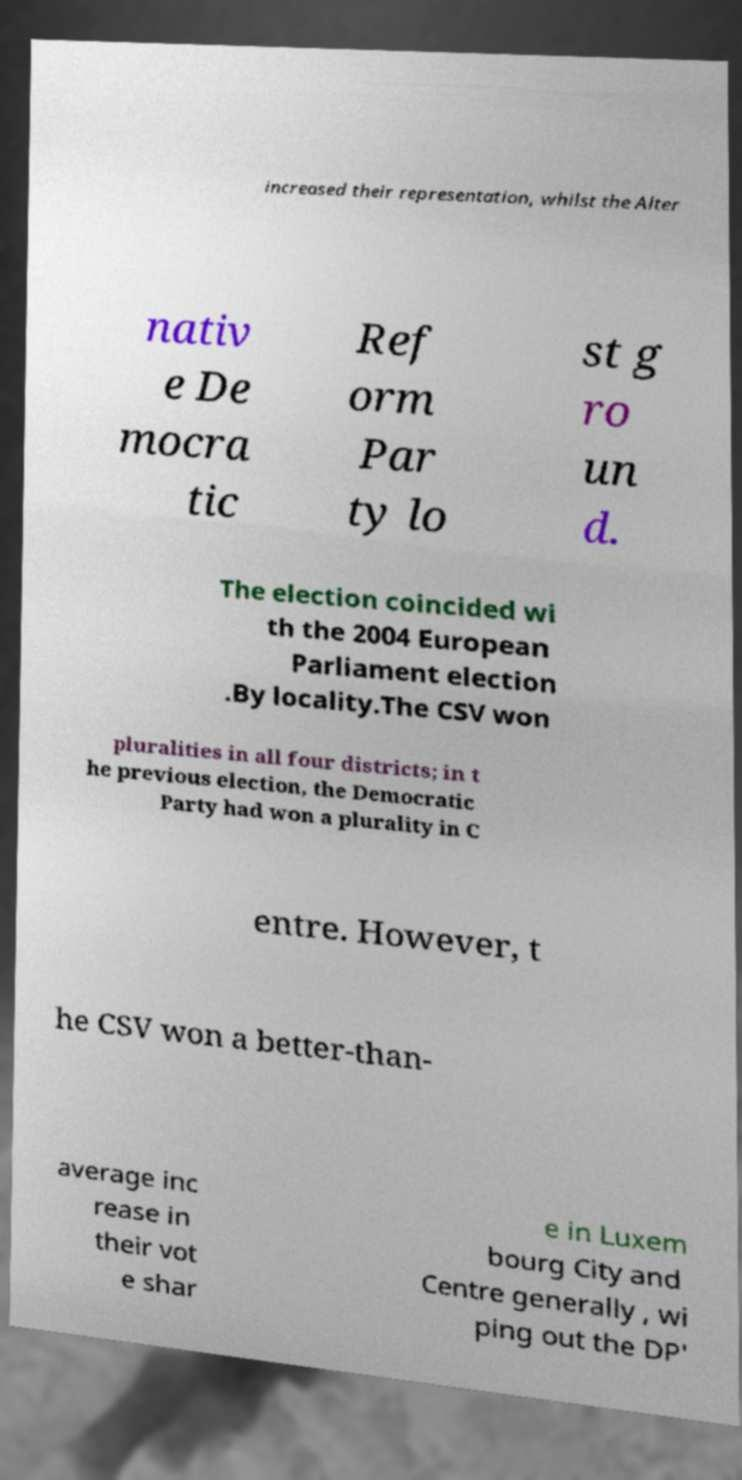What messages or text are displayed in this image? I need them in a readable, typed format. increased their representation, whilst the Alter nativ e De mocra tic Ref orm Par ty lo st g ro un d. The election coincided wi th the 2004 European Parliament election .By locality.The CSV won pluralities in all four districts; in t he previous election, the Democratic Party had won a plurality in C entre. However, t he CSV won a better-than- average inc rease in their vot e shar e in Luxem bourg City and Centre generally , wi ping out the DP' 